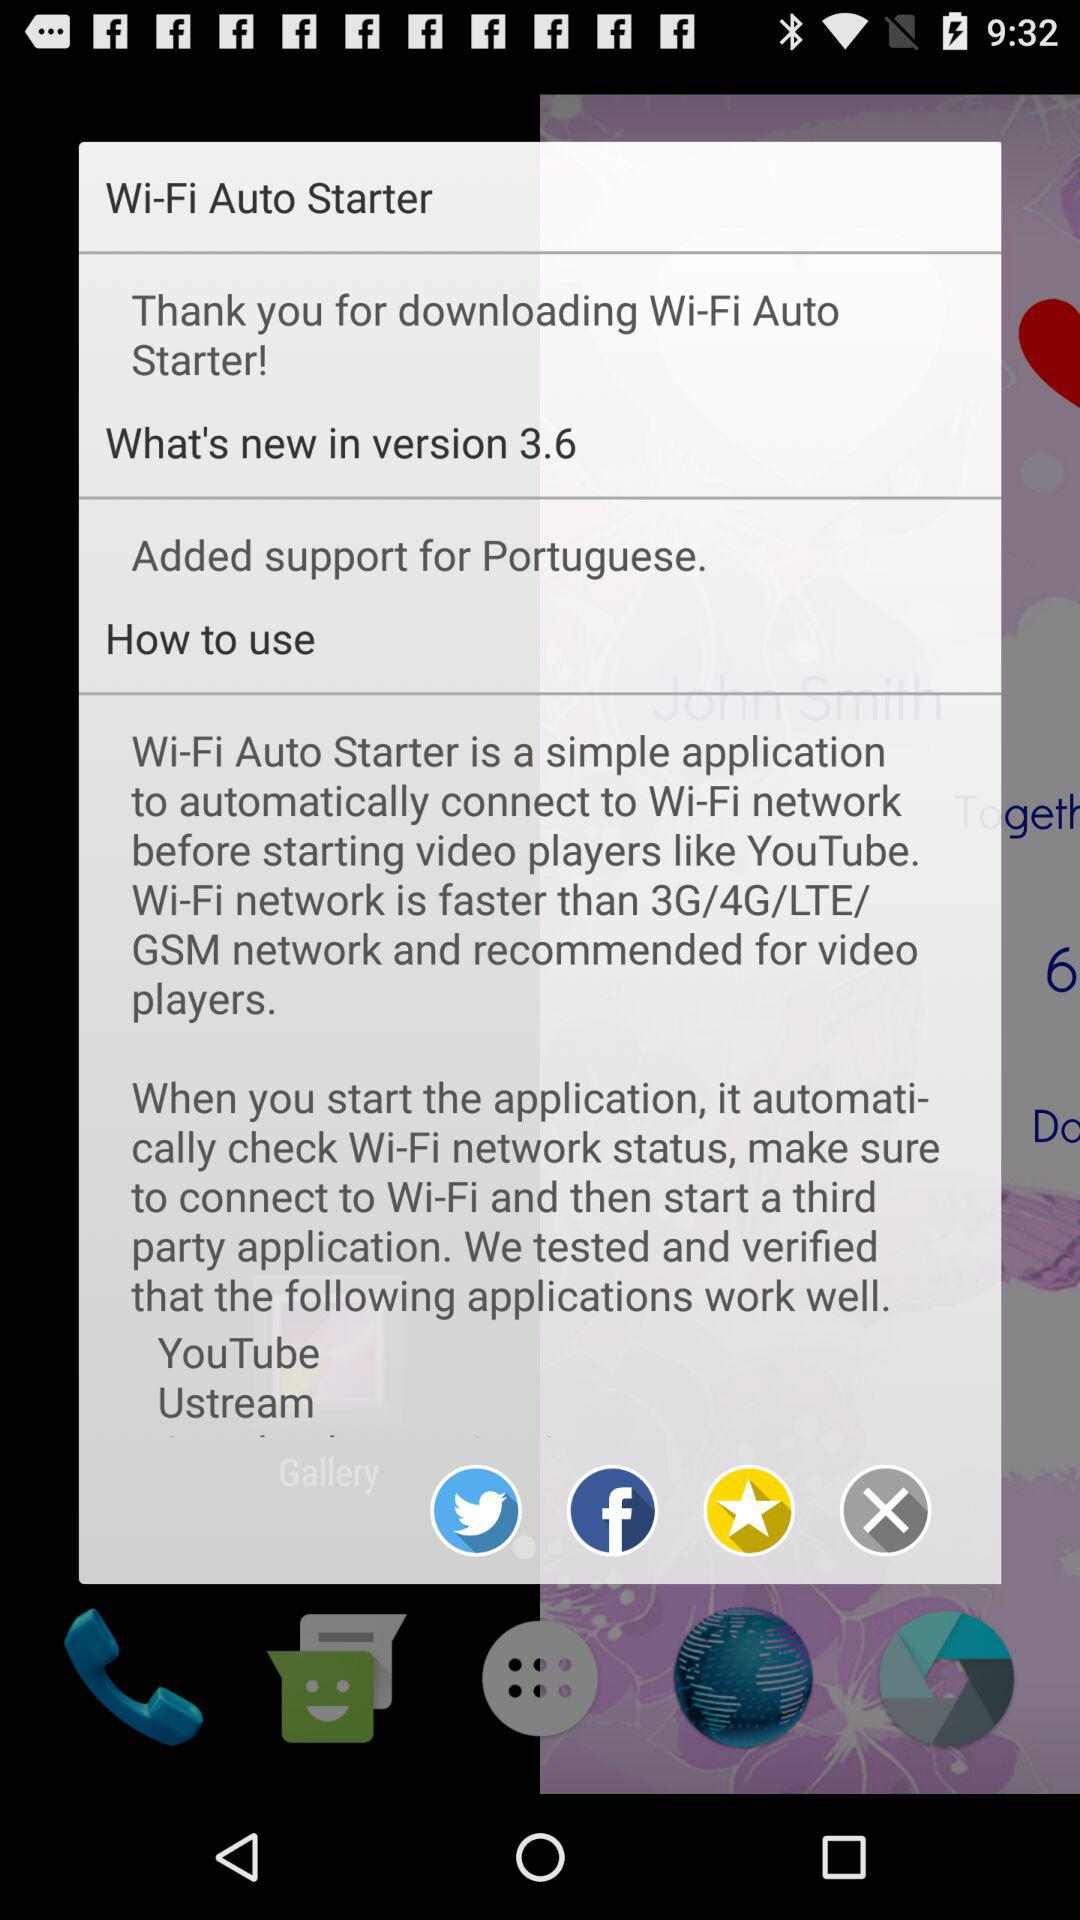What is the new feature in version 3.6? The new feature is "Added support for Portuguese". 